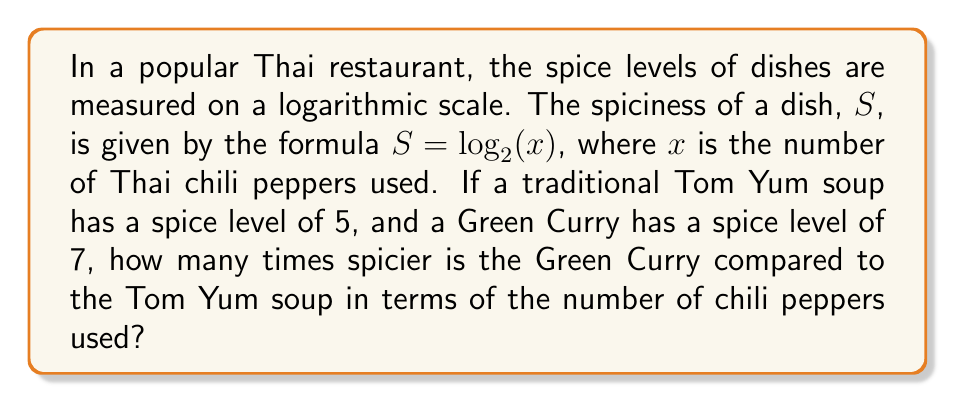What is the answer to this math problem? Let's approach this step-by-step:

1) For Tom Yum soup:
   $S_1 = 5 = \log_2(x_1)$
   where $x_1$ is the number of chili peppers in Tom Yum

2) For Green Curry:
   $S_2 = 7 = \log_2(x_2)$
   where $x_2$ is the number of chili peppers in Green Curry

3) To find $x_1$ and $x_2$, we need to use the inverse function of $\log_2$, which is $2^x$:

   For Tom Yum: $x_1 = 2^{S_1} = 2^5 = 32$ peppers
   For Green Curry: $x_2 = 2^{S_2} = 2^7 = 128$ peppers

4) To compare how many times spicier the Green Curry is, we divide $x_2$ by $x_1$:

   $\frac{x_2}{x_1} = \frac{128}{32} = 4$

Therefore, the Green Curry is 4 times spicier than the Tom Yum soup in terms of the number of chili peppers used.
Answer: 4 times spicier 